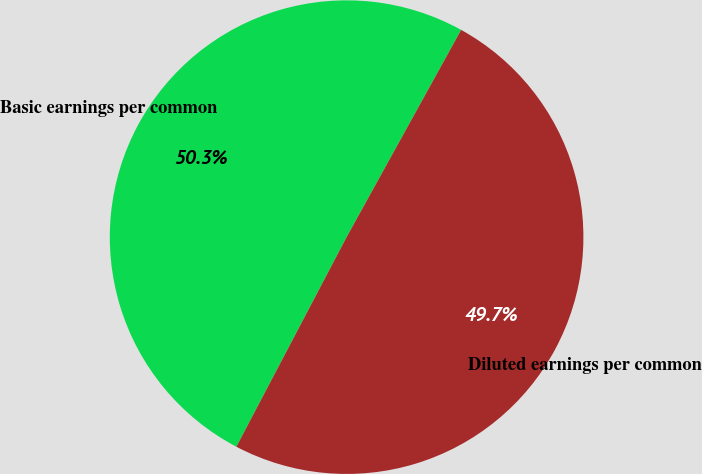Convert chart to OTSL. <chart><loc_0><loc_0><loc_500><loc_500><pie_chart><fcel>Basic earnings per common<fcel>Diluted earnings per common<nl><fcel>50.33%<fcel>49.67%<nl></chart> 